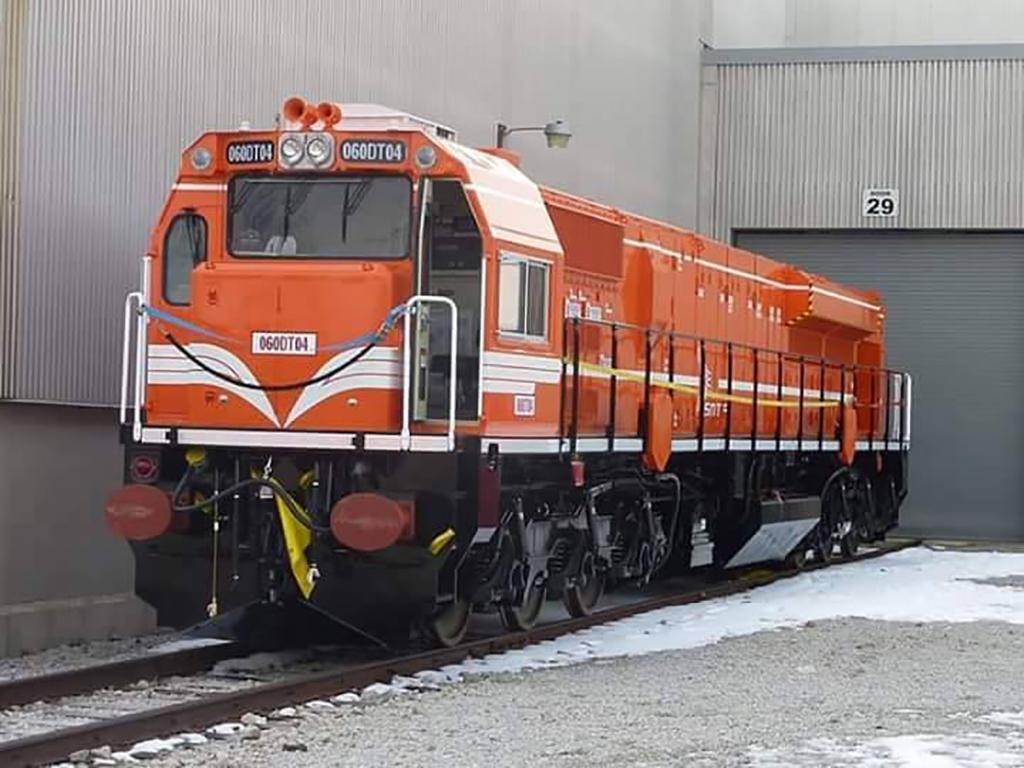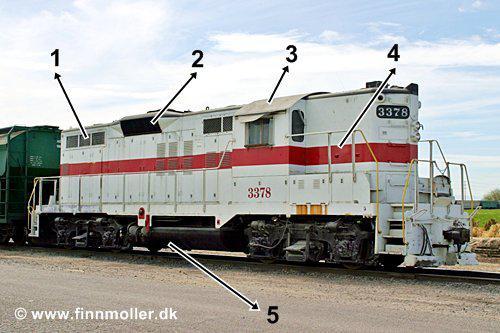The first image is the image on the left, the second image is the image on the right. Evaluate the accuracy of this statement regarding the images: "The engine in the image on the right is white with a red stripe on it.". Is it true? Answer yes or no. Yes. The first image is the image on the left, the second image is the image on the right. Analyze the images presented: Is the assertion "One train is primarily white with at least one red stripe, and the other train is primarily red with a pale stripe." valid? Answer yes or no. Yes. 